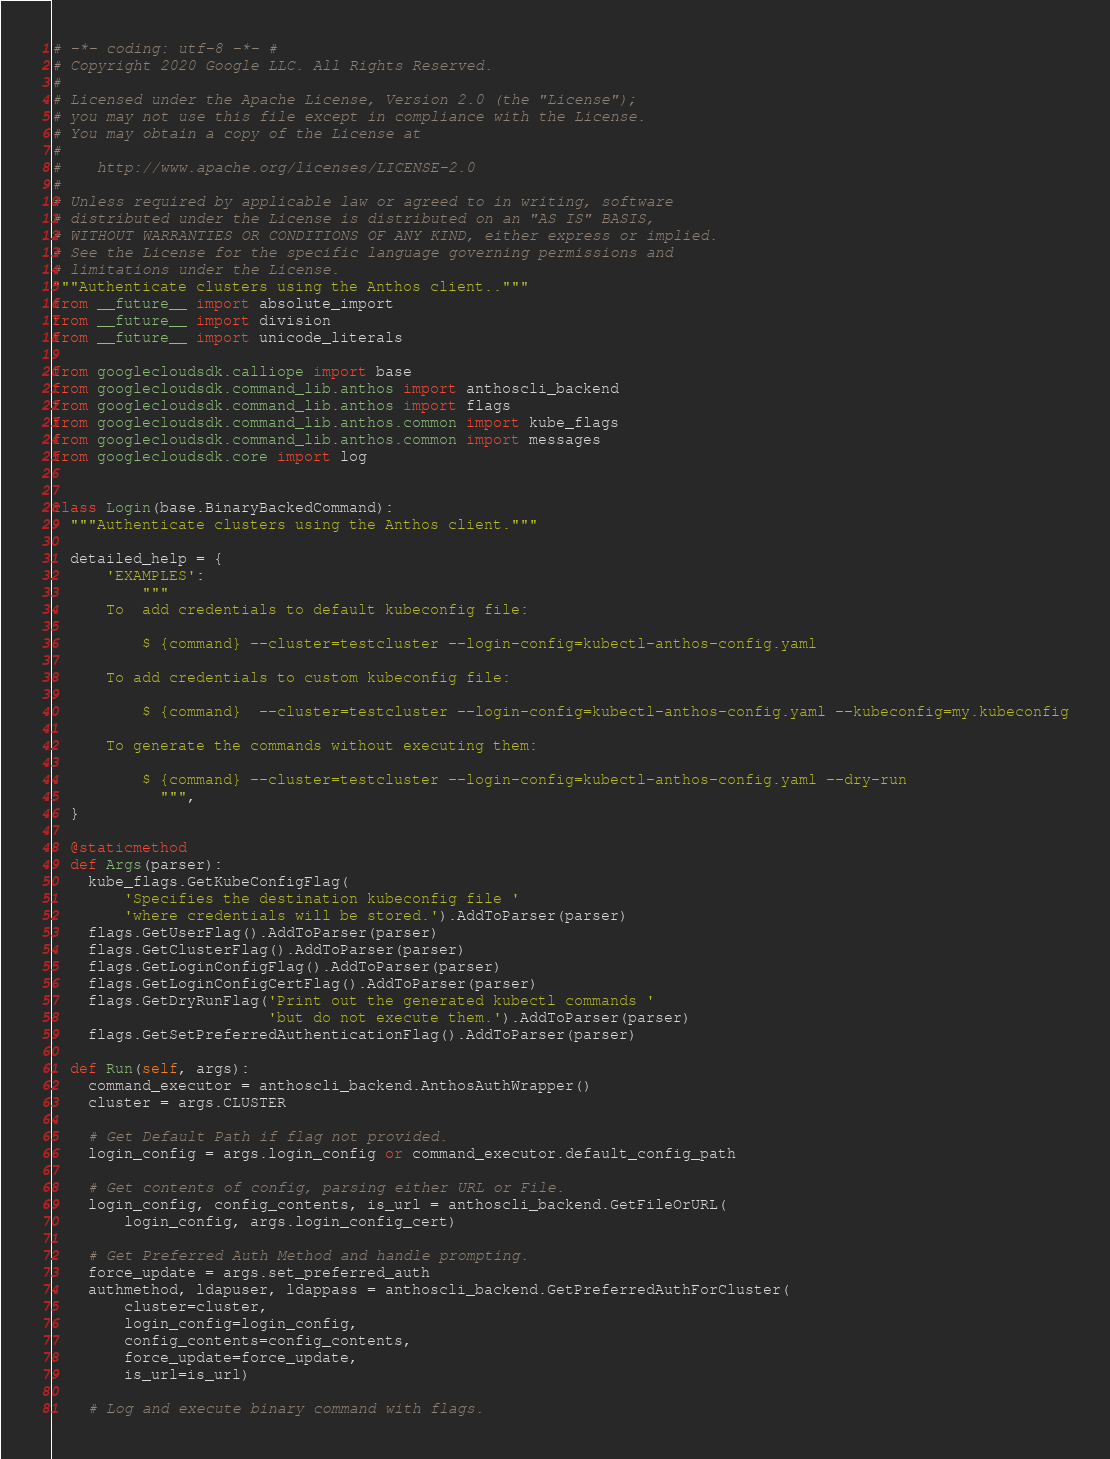Convert code to text. <code><loc_0><loc_0><loc_500><loc_500><_Python_># -*- coding: utf-8 -*- #
# Copyright 2020 Google LLC. All Rights Reserved.
#
# Licensed under the Apache License, Version 2.0 (the "License");
# you may not use this file except in compliance with the License.
# You may obtain a copy of the License at
#
#    http://www.apache.org/licenses/LICENSE-2.0
#
# Unless required by applicable law or agreed to in writing, software
# distributed under the License is distributed on an "AS IS" BASIS,
# WITHOUT WARRANTIES OR CONDITIONS OF ANY KIND, either express or implied.
# See the License for the specific language governing permissions and
# limitations under the License.
"""Authenticate clusters using the Anthos client.."""
from __future__ import absolute_import
from __future__ import division
from __future__ import unicode_literals

from googlecloudsdk.calliope import base
from googlecloudsdk.command_lib.anthos import anthoscli_backend
from googlecloudsdk.command_lib.anthos import flags
from googlecloudsdk.command_lib.anthos.common import kube_flags
from googlecloudsdk.command_lib.anthos.common import messages
from googlecloudsdk.core import log


class Login(base.BinaryBackedCommand):
  """Authenticate clusters using the Anthos client."""

  detailed_help = {
      'EXAMPLES':
          """
      To  add credentials to default kubeconfig file:

          $ {command} --cluster=testcluster --login-config=kubectl-anthos-config.yaml

      To add credentials to custom kubeconfig file:

          $ {command}  --cluster=testcluster --login-config=kubectl-anthos-config.yaml --kubeconfig=my.kubeconfig

      To generate the commands without executing them:

          $ {command} --cluster=testcluster --login-config=kubectl-anthos-config.yaml --dry-run
            """,
  }

  @staticmethod
  def Args(parser):
    kube_flags.GetKubeConfigFlag(
        'Specifies the destination kubeconfig file '
        'where credentials will be stored.').AddToParser(parser)
    flags.GetUserFlag().AddToParser(parser)
    flags.GetClusterFlag().AddToParser(parser)
    flags.GetLoginConfigFlag().AddToParser(parser)
    flags.GetLoginConfigCertFlag().AddToParser(parser)
    flags.GetDryRunFlag('Print out the generated kubectl commands '
                        'but do not execute them.').AddToParser(parser)
    flags.GetSetPreferredAuthenticationFlag().AddToParser(parser)

  def Run(self, args):
    command_executor = anthoscli_backend.AnthosAuthWrapper()
    cluster = args.CLUSTER

    # Get Default Path if flag not provided.
    login_config = args.login_config or command_executor.default_config_path

    # Get contents of config, parsing either URL or File.
    login_config, config_contents, is_url = anthoscli_backend.GetFileOrURL(
        login_config, args.login_config_cert)

    # Get Preferred Auth Method and handle prompting.
    force_update = args.set_preferred_auth
    authmethod, ldapuser, ldappass = anthoscli_backend.GetPreferredAuthForCluster(
        cluster=cluster,
        login_config=login_config,
        config_contents=config_contents,
        force_update=force_update,
        is_url=is_url)

    # Log and execute binary command with flags.</code> 